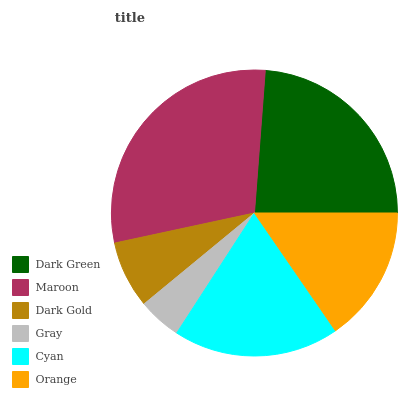Is Gray the minimum?
Answer yes or no. Yes. Is Maroon the maximum?
Answer yes or no. Yes. Is Dark Gold the minimum?
Answer yes or no. No. Is Dark Gold the maximum?
Answer yes or no. No. Is Maroon greater than Dark Gold?
Answer yes or no. Yes. Is Dark Gold less than Maroon?
Answer yes or no. Yes. Is Dark Gold greater than Maroon?
Answer yes or no. No. Is Maroon less than Dark Gold?
Answer yes or no. No. Is Cyan the high median?
Answer yes or no. Yes. Is Orange the low median?
Answer yes or no. Yes. Is Maroon the high median?
Answer yes or no. No. Is Cyan the low median?
Answer yes or no. No. 